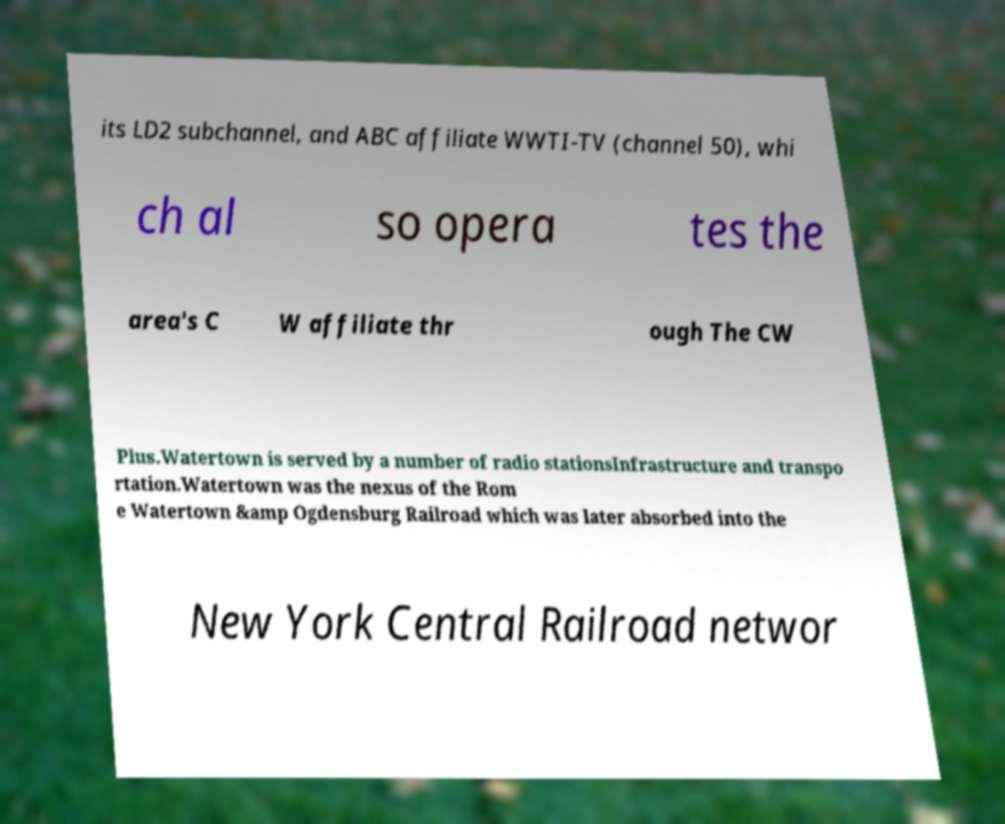For documentation purposes, I need the text within this image transcribed. Could you provide that? its LD2 subchannel, and ABC affiliate WWTI-TV (channel 50), whi ch al so opera tes the area's C W affiliate thr ough The CW Plus.Watertown is served by a number of radio stationsInfrastructure and transpo rtation.Watertown was the nexus of the Rom e Watertown &amp Ogdensburg Railroad which was later absorbed into the New York Central Railroad networ 